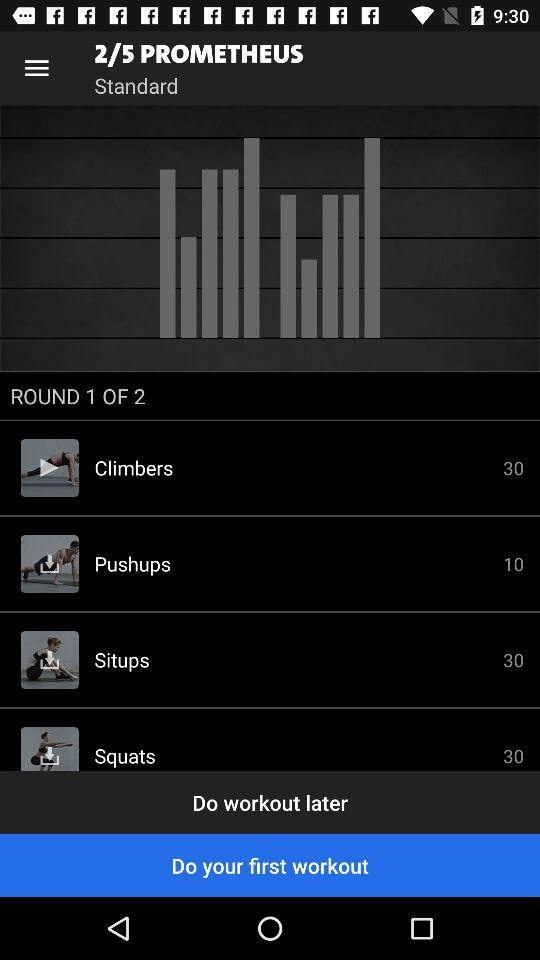How many exercises are there in the workout?
Answer the question using a single word or phrase. 4 